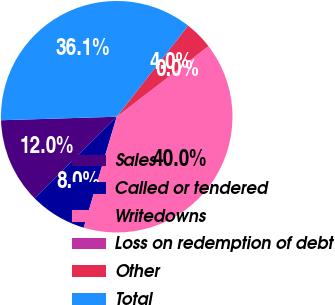<chart> <loc_0><loc_0><loc_500><loc_500><pie_chart><fcel>Sales<fcel>Called or tendered<fcel>Writedowns<fcel>Loss on redemption of debt<fcel>Other<fcel>Total<nl><fcel>11.95%<fcel>7.96%<fcel>40.04%<fcel>0.0%<fcel>3.98%<fcel>36.06%<nl></chart> 